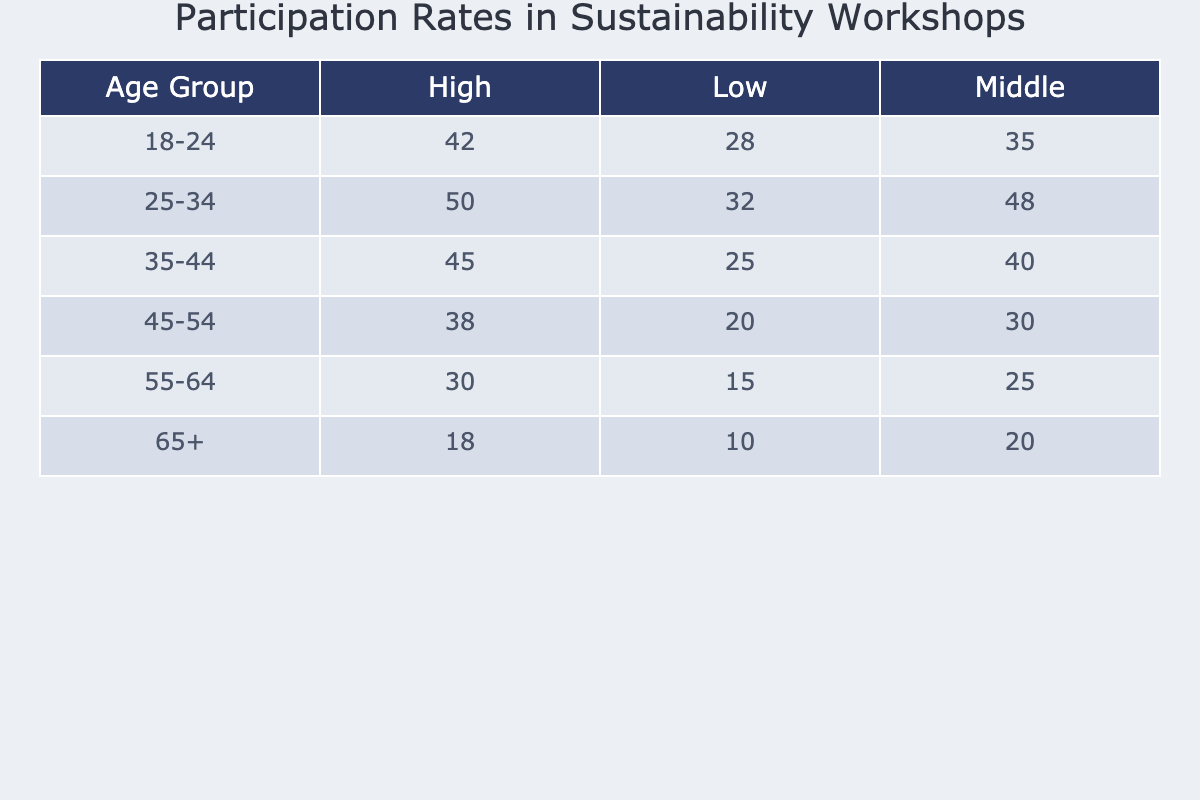What is the participation rate for the 18-24 age group with a high income level? According to the table, in the row for the 18-24 age group and the column for high income, the participation rate is 42%.
Answer: 42% Which age group has the lowest participation rate among individuals with a low income level? The table shows that the 65+ age group has the lowest participation rate at 10% for the low income level.
Answer: 10% What is the participation rate difference between the 25-34 and 35-44 age groups for middle income individuals? For the 25-34 age group, the participation rate is 48%, and for the 35-44 age group, it is 40%. The difference is 48% - 40% = 8%.
Answer: 8% Is the participation rate for low income individuals in the 45-54 age group greater than that of the 55-64 age group? Yes, the participation rate for the 45-54 age group is 20%, which is higher than the 15% for the 55-64 age group.
Answer: Yes What is the average participation rate for the high income level across all age groups? To find the average, we take the values for the high income level: 42 (18-24) + 50 (25-34) + 45 (35-44) + 38 (45-54) + 30 (55-64) + 18 (65+), which sums to 223. There are 6 data points, so the average is 223/6 = 37.17%.
Answer: 37.17% If we compare the participation rates of the low income group across all age groups, what is the maximum participation rate and which age group does it belong to? From the table, the participation rate for low income individuals is 28% (18-24), 32% (25-34), 25% (35-44), 20% (45-54), 15% (55-64), and 10% (65+). The maximum rate is 32% from the 25-34 age group.
Answer: 32%, 25-34 What is the trend observed in participation rates among older age groups for middle income individuals? The middle income participation rates show a decrease as age increases: 48% (25-34), 40% (35-44), 30% (45-54), 25% (55-64), and 20% (65+). This indicates a downward trend.
Answer: Downward trend 